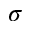<formula> <loc_0><loc_0><loc_500><loc_500>\sigma</formula> 